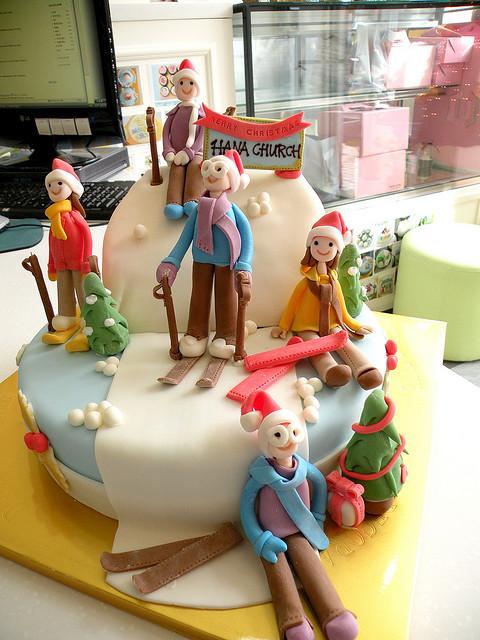What season is depicted on the cake?
Keep it brief. Winter. Is this cake homemade?
Answer briefly. No. Is it an indoor scene?
Short answer required. Yes. 